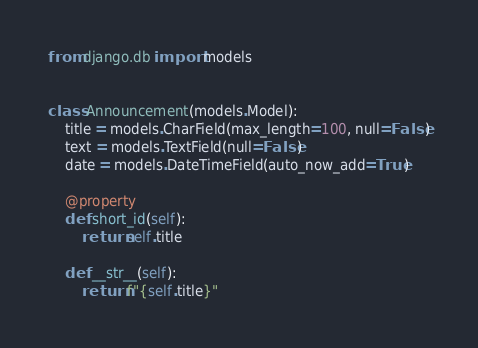<code> <loc_0><loc_0><loc_500><loc_500><_Python_>from django.db import models


class Announcement(models.Model):
    title = models.CharField(max_length=100, null=False)
    text = models.TextField(null=False)
    date = models.DateTimeField(auto_now_add=True)

    @property
    def short_id(self):
        return self.title

    def __str__(self):
        return f"{self.title}"
</code> 